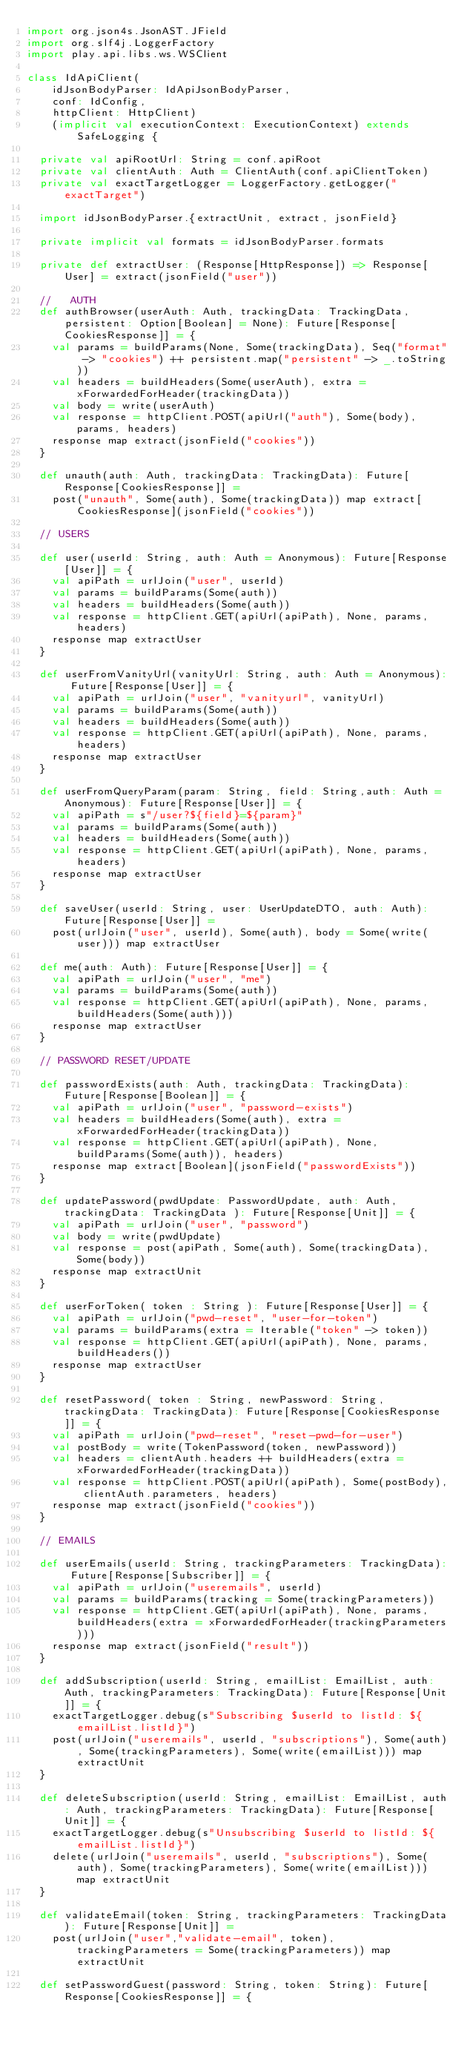<code> <loc_0><loc_0><loc_500><loc_500><_Scala_>import org.json4s.JsonAST.JField
import org.slf4j.LoggerFactory
import play.api.libs.ws.WSClient

class IdApiClient(
    idJsonBodyParser: IdApiJsonBodyParser,
    conf: IdConfig,
    httpClient: HttpClient)
    (implicit val executionContext: ExecutionContext) extends SafeLogging {

  private val apiRootUrl: String = conf.apiRoot
  private val clientAuth: Auth = ClientAuth(conf.apiClientToken)
  private val exactTargetLogger = LoggerFactory.getLogger("exactTarget")

  import idJsonBodyParser.{extractUnit, extract, jsonField}

  private implicit val formats = idJsonBodyParser.formats

  private def extractUser: (Response[HttpResponse]) => Response[User] = extract(jsonField("user"))

  //   AUTH
  def authBrowser(userAuth: Auth, trackingData: TrackingData, persistent: Option[Boolean] = None): Future[Response[CookiesResponse]] = {
    val params = buildParams(None, Some(trackingData), Seq("format" -> "cookies") ++ persistent.map("persistent" -> _.toString))
    val headers = buildHeaders(Some(userAuth), extra = xForwardedForHeader(trackingData))
    val body = write(userAuth)
    val response = httpClient.POST(apiUrl("auth"), Some(body), params, headers)
    response map extract(jsonField("cookies"))
  }

  def unauth(auth: Auth, trackingData: TrackingData): Future[Response[CookiesResponse]] =
    post("unauth", Some(auth), Some(trackingData)) map extract[CookiesResponse](jsonField("cookies"))

  // USERS

  def user(userId: String, auth: Auth = Anonymous): Future[Response[User]] = {
    val apiPath = urlJoin("user", userId)
    val params = buildParams(Some(auth))
    val headers = buildHeaders(Some(auth))
    val response = httpClient.GET(apiUrl(apiPath), None, params, headers)
    response map extractUser
  }

  def userFromVanityUrl(vanityUrl: String, auth: Auth = Anonymous): Future[Response[User]] = {
    val apiPath = urlJoin("user", "vanityurl", vanityUrl)
    val params = buildParams(Some(auth))
    val headers = buildHeaders(Some(auth))
    val response = httpClient.GET(apiUrl(apiPath), None, params, headers)
    response map extractUser
  }

  def userFromQueryParam(param: String, field: String,auth: Auth = Anonymous): Future[Response[User]] = {
    val apiPath = s"/user?${field}=${param}"
    val params = buildParams(Some(auth))
    val headers = buildHeaders(Some(auth))
    val response = httpClient.GET(apiUrl(apiPath), None, params, headers)
    response map extractUser
  }

  def saveUser(userId: String, user: UserUpdateDTO, auth: Auth): Future[Response[User]] =
    post(urlJoin("user", userId), Some(auth), body = Some(write(user))) map extractUser

  def me(auth: Auth): Future[Response[User]] = {
    val apiPath = urlJoin("user", "me")
    val params = buildParams(Some(auth))
    val response = httpClient.GET(apiUrl(apiPath), None, params, buildHeaders(Some(auth)))
    response map extractUser
  }

  // PASSWORD RESET/UPDATE

  def passwordExists(auth: Auth, trackingData: TrackingData): Future[Response[Boolean]] = {
    val apiPath = urlJoin("user", "password-exists")
    val headers = buildHeaders(Some(auth), extra = xForwardedForHeader(trackingData))
    val response = httpClient.GET(apiUrl(apiPath), None, buildParams(Some(auth)), headers)
    response map extract[Boolean](jsonField("passwordExists"))
  }

  def updatePassword(pwdUpdate: PasswordUpdate, auth: Auth, trackingData: TrackingData ): Future[Response[Unit]] = {
    val apiPath = urlJoin("user", "password")
    val body = write(pwdUpdate)
    val response = post(apiPath, Some(auth), Some(trackingData), Some(body))
    response map extractUnit
  }

  def userForToken( token : String ): Future[Response[User]] = {
    val apiPath = urlJoin("pwd-reset", "user-for-token")
    val params = buildParams(extra = Iterable("token" -> token))
    val response = httpClient.GET(apiUrl(apiPath), None, params, buildHeaders())
    response map extractUser
  }

  def resetPassword( token : String, newPassword: String, trackingData: TrackingData): Future[Response[CookiesResponse]] = {
    val apiPath = urlJoin("pwd-reset", "reset-pwd-for-user")
    val postBody = write(TokenPassword(token, newPassword))
    val headers = clientAuth.headers ++ buildHeaders(extra = xForwardedForHeader(trackingData))
    val response = httpClient.POST(apiUrl(apiPath), Some(postBody), clientAuth.parameters, headers)
    response map extract(jsonField("cookies"))
  }

  // EMAILS

  def userEmails(userId: String, trackingParameters: TrackingData): Future[Response[Subscriber]] = {
    val apiPath = urlJoin("useremails", userId)
    val params = buildParams(tracking = Some(trackingParameters))
    val response = httpClient.GET(apiUrl(apiPath), None, params, buildHeaders(extra = xForwardedForHeader(trackingParameters)))
    response map extract(jsonField("result"))
  }

  def addSubscription(userId: String, emailList: EmailList, auth: Auth, trackingParameters: TrackingData): Future[Response[Unit]] = {
    exactTargetLogger.debug(s"Subscribing $userId to listId: ${emailList.listId}")
    post(urlJoin("useremails", userId, "subscriptions"), Some(auth), Some(trackingParameters), Some(write(emailList))) map extractUnit
  }

  def deleteSubscription(userId: String, emailList: EmailList, auth: Auth, trackingParameters: TrackingData): Future[Response[Unit]] = {
    exactTargetLogger.debug(s"Unsubscribing $userId to listId: ${emailList.listId}")
    delete(urlJoin("useremails", userId, "subscriptions"), Some(auth), Some(trackingParameters), Some(write(emailList))) map extractUnit
  }

  def validateEmail(token: String, trackingParameters: TrackingData): Future[Response[Unit]] =
    post(urlJoin("user","validate-email", token), trackingParameters = Some(trackingParameters)) map extractUnit

  def setPasswordGuest(password: String, token: String): Future[Response[CookiesResponse]] = {</code> 